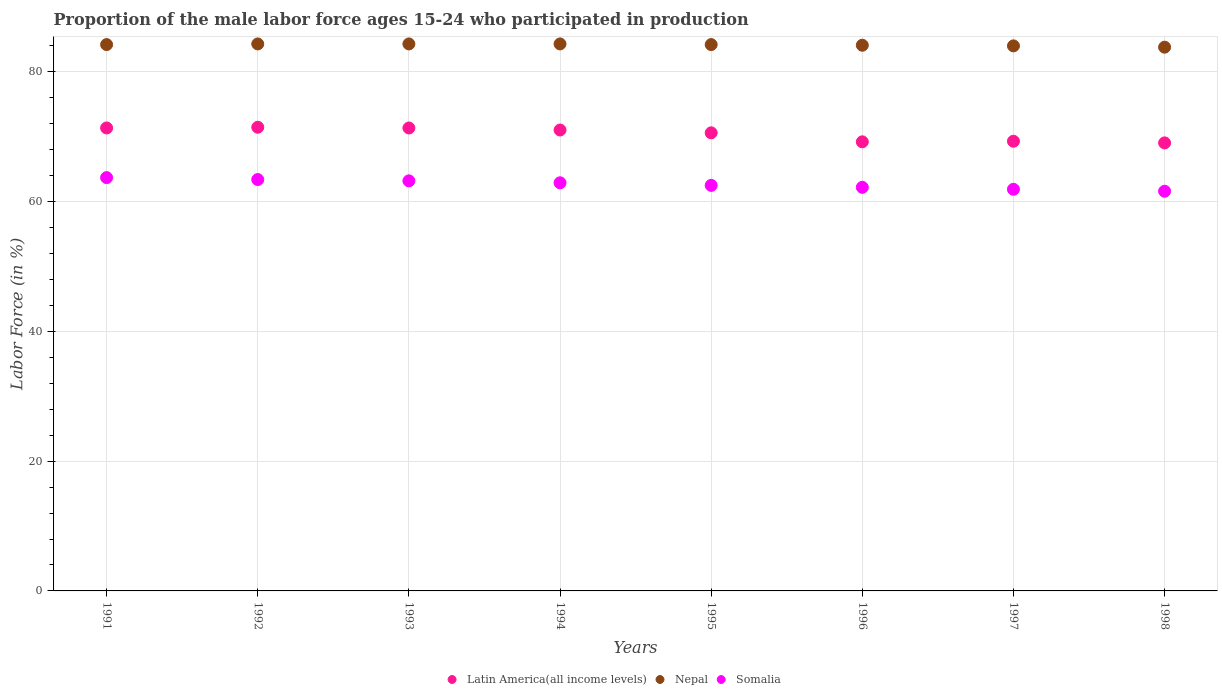How many different coloured dotlines are there?
Keep it short and to the point. 3. What is the proportion of the male labor force who participated in production in Somalia in 1998?
Ensure brevity in your answer.  61.6. Across all years, what is the maximum proportion of the male labor force who participated in production in Latin America(all income levels)?
Give a very brief answer. 71.46. Across all years, what is the minimum proportion of the male labor force who participated in production in Somalia?
Provide a succinct answer. 61.6. In which year was the proportion of the male labor force who participated in production in Nepal maximum?
Give a very brief answer. 1992. What is the total proportion of the male labor force who participated in production in Latin America(all income levels) in the graph?
Provide a short and direct response. 563.37. What is the difference between the proportion of the male labor force who participated in production in Somalia in 1997 and that in 1998?
Keep it short and to the point. 0.3. What is the difference between the proportion of the male labor force who participated in production in Nepal in 1991 and the proportion of the male labor force who participated in production in Latin America(all income levels) in 1994?
Your response must be concise. 13.17. What is the average proportion of the male labor force who participated in production in Latin America(all income levels) per year?
Your answer should be very brief. 70.42. In the year 1994, what is the difference between the proportion of the male labor force who participated in production in Somalia and proportion of the male labor force who participated in production in Nepal?
Make the answer very short. -21.4. In how many years, is the proportion of the male labor force who participated in production in Latin America(all income levels) greater than 72 %?
Your answer should be compact. 0. What is the ratio of the proportion of the male labor force who participated in production in Latin America(all income levels) in 1994 to that in 1996?
Your answer should be compact. 1.03. Is the proportion of the male labor force who participated in production in Latin America(all income levels) in 1995 less than that in 1998?
Offer a terse response. No. Is the difference between the proportion of the male labor force who participated in production in Somalia in 1993 and 1997 greater than the difference between the proportion of the male labor force who participated in production in Nepal in 1993 and 1997?
Your response must be concise. Yes. What is the difference between the highest and the second highest proportion of the male labor force who participated in production in Nepal?
Ensure brevity in your answer.  0. What is the difference between the highest and the lowest proportion of the male labor force who participated in production in Latin America(all income levels)?
Offer a very short reply. 2.41. Is the sum of the proportion of the male labor force who participated in production in Somalia in 1997 and 1998 greater than the maximum proportion of the male labor force who participated in production in Latin America(all income levels) across all years?
Provide a succinct answer. Yes. Is the proportion of the male labor force who participated in production in Somalia strictly less than the proportion of the male labor force who participated in production in Nepal over the years?
Provide a short and direct response. Yes. How many years are there in the graph?
Ensure brevity in your answer.  8. Does the graph contain grids?
Ensure brevity in your answer.  Yes. Where does the legend appear in the graph?
Provide a short and direct response. Bottom center. How many legend labels are there?
Offer a terse response. 3. What is the title of the graph?
Your response must be concise. Proportion of the male labor force ages 15-24 who participated in production. What is the Labor Force (in %) of Latin America(all income levels) in 1991?
Your answer should be very brief. 71.35. What is the Labor Force (in %) of Nepal in 1991?
Your answer should be very brief. 84.2. What is the Labor Force (in %) of Somalia in 1991?
Ensure brevity in your answer.  63.7. What is the Labor Force (in %) in Latin America(all income levels) in 1992?
Keep it short and to the point. 71.46. What is the Labor Force (in %) of Nepal in 1992?
Your answer should be compact. 84.3. What is the Labor Force (in %) of Somalia in 1992?
Keep it short and to the point. 63.4. What is the Labor Force (in %) of Latin America(all income levels) in 1993?
Provide a succinct answer. 71.35. What is the Labor Force (in %) in Nepal in 1993?
Give a very brief answer. 84.3. What is the Labor Force (in %) in Somalia in 1993?
Offer a terse response. 63.2. What is the Labor Force (in %) in Latin America(all income levels) in 1994?
Provide a succinct answer. 71.03. What is the Labor Force (in %) in Nepal in 1994?
Your answer should be very brief. 84.3. What is the Labor Force (in %) of Somalia in 1994?
Offer a terse response. 62.9. What is the Labor Force (in %) of Latin America(all income levels) in 1995?
Your answer should be very brief. 70.6. What is the Labor Force (in %) of Nepal in 1995?
Offer a very short reply. 84.2. What is the Labor Force (in %) in Somalia in 1995?
Keep it short and to the point. 62.5. What is the Labor Force (in %) of Latin America(all income levels) in 1996?
Make the answer very short. 69.21. What is the Labor Force (in %) in Nepal in 1996?
Your answer should be very brief. 84.1. What is the Labor Force (in %) in Somalia in 1996?
Offer a terse response. 62.2. What is the Labor Force (in %) in Latin America(all income levels) in 1997?
Ensure brevity in your answer.  69.31. What is the Labor Force (in %) of Somalia in 1997?
Keep it short and to the point. 61.9. What is the Labor Force (in %) of Latin America(all income levels) in 1998?
Provide a short and direct response. 69.05. What is the Labor Force (in %) of Nepal in 1998?
Provide a short and direct response. 83.8. What is the Labor Force (in %) of Somalia in 1998?
Ensure brevity in your answer.  61.6. Across all years, what is the maximum Labor Force (in %) in Latin America(all income levels)?
Provide a short and direct response. 71.46. Across all years, what is the maximum Labor Force (in %) in Nepal?
Make the answer very short. 84.3. Across all years, what is the maximum Labor Force (in %) of Somalia?
Your response must be concise. 63.7. Across all years, what is the minimum Labor Force (in %) in Latin America(all income levels)?
Provide a short and direct response. 69.05. Across all years, what is the minimum Labor Force (in %) in Nepal?
Your response must be concise. 83.8. Across all years, what is the minimum Labor Force (in %) of Somalia?
Provide a succinct answer. 61.6. What is the total Labor Force (in %) of Latin America(all income levels) in the graph?
Your answer should be very brief. 563.37. What is the total Labor Force (in %) of Nepal in the graph?
Your response must be concise. 673.2. What is the total Labor Force (in %) of Somalia in the graph?
Make the answer very short. 501.4. What is the difference between the Labor Force (in %) in Latin America(all income levels) in 1991 and that in 1992?
Give a very brief answer. -0.11. What is the difference between the Labor Force (in %) of Latin America(all income levels) in 1991 and that in 1993?
Ensure brevity in your answer.  0. What is the difference between the Labor Force (in %) in Nepal in 1991 and that in 1993?
Make the answer very short. -0.1. What is the difference between the Labor Force (in %) of Latin America(all income levels) in 1991 and that in 1994?
Your answer should be compact. 0.32. What is the difference between the Labor Force (in %) in Latin America(all income levels) in 1991 and that in 1995?
Offer a terse response. 0.75. What is the difference between the Labor Force (in %) in Nepal in 1991 and that in 1995?
Offer a terse response. 0. What is the difference between the Labor Force (in %) of Somalia in 1991 and that in 1995?
Provide a short and direct response. 1.2. What is the difference between the Labor Force (in %) in Latin America(all income levels) in 1991 and that in 1996?
Provide a succinct answer. 2.14. What is the difference between the Labor Force (in %) of Nepal in 1991 and that in 1996?
Offer a terse response. 0.1. What is the difference between the Labor Force (in %) in Latin America(all income levels) in 1991 and that in 1997?
Provide a succinct answer. 2.05. What is the difference between the Labor Force (in %) in Somalia in 1991 and that in 1997?
Provide a succinct answer. 1.8. What is the difference between the Labor Force (in %) of Latin America(all income levels) in 1991 and that in 1998?
Offer a very short reply. 2.3. What is the difference between the Labor Force (in %) in Nepal in 1991 and that in 1998?
Your response must be concise. 0.4. What is the difference between the Labor Force (in %) of Latin America(all income levels) in 1992 and that in 1993?
Your response must be concise. 0.11. What is the difference between the Labor Force (in %) in Nepal in 1992 and that in 1993?
Provide a succinct answer. 0. What is the difference between the Labor Force (in %) in Somalia in 1992 and that in 1993?
Offer a terse response. 0.2. What is the difference between the Labor Force (in %) of Latin America(all income levels) in 1992 and that in 1994?
Keep it short and to the point. 0.43. What is the difference between the Labor Force (in %) in Latin America(all income levels) in 1992 and that in 1995?
Your answer should be very brief. 0.86. What is the difference between the Labor Force (in %) of Nepal in 1992 and that in 1995?
Make the answer very short. 0.1. What is the difference between the Labor Force (in %) of Latin America(all income levels) in 1992 and that in 1996?
Give a very brief answer. 2.25. What is the difference between the Labor Force (in %) of Nepal in 1992 and that in 1996?
Offer a very short reply. 0.2. What is the difference between the Labor Force (in %) of Somalia in 1992 and that in 1996?
Ensure brevity in your answer.  1.2. What is the difference between the Labor Force (in %) in Latin America(all income levels) in 1992 and that in 1997?
Offer a terse response. 2.16. What is the difference between the Labor Force (in %) of Nepal in 1992 and that in 1997?
Offer a terse response. 0.3. What is the difference between the Labor Force (in %) in Somalia in 1992 and that in 1997?
Make the answer very short. 1.5. What is the difference between the Labor Force (in %) of Latin America(all income levels) in 1992 and that in 1998?
Your response must be concise. 2.41. What is the difference between the Labor Force (in %) of Latin America(all income levels) in 1993 and that in 1994?
Offer a terse response. 0.31. What is the difference between the Labor Force (in %) in Nepal in 1993 and that in 1994?
Offer a terse response. 0. What is the difference between the Labor Force (in %) of Somalia in 1993 and that in 1994?
Your response must be concise. 0.3. What is the difference between the Labor Force (in %) of Latin America(all income levels) in 1993 and that in 1995?
Provide a succinct answer. 0.75. What is the difference between the Labor Force (in %) in Nepal in 1993 and that in 1995?
Give a very brief answer. 0.1. What is the difference between the Labor Force (in %) in Somalia in 1993 and that in 1995?
Offer a very short reply. 0.7. What is the difference between the Labor Force (in %) in Latin America(all income levels) in 1993 and that in 1996?
Provide a short and direct response. 2.13. What is the difference between the Labor Force (in %) in Nepal in 1993 and that in 1996?
Your answer should be very brief. 0.2. What is the difference between the Labor Force (in %) in Somalia in 1993 and that in 1996?
Give a very brief answer. 1. What is the difference between the Labor Force (in %) in Latin America(all income levels) in 1993 and that in 1997?
Your answer should be compact. 2.04. What is the difference between the Labor Force (in %) of Nepal in 1993 and that in 1997?
Keep it short and to the point. 0.3. What is the difference between the Labor Force (in %) of Somalia in 1993 and that in 1997?
Your answer should be compact. 1.3. What is the difference between the Labor Force (in %) in Latin America(all income levels) in 1993 and that in 1998?
Offer a very short reply. 2.3. What is the difference between the Labor Force (in %) of Latin America(all income levels) in 1994 and that in 1995?
Ensure brevity in your answer.  0.43. What is the difference between the Labor Force (in %) of Nepal in 1994 and that in 1995?
Keep it short and to the point. 0.1. What is the difference between the Labor Force (in %) of Somalia in 1994 and that in 1995?
Keep it short and to the point. 0.4. What is the difference between the Labor Force (in %) of Latin America(all income levels) in 1994 and that in 1996?
Keep it short and to the point. 1.82. What is the difference between the Labor Force (in %) of Nepal in 1994 and that in 1996?
Make the answer very short. 0.2. What is the difference between the Labor Force (in %) of Latin America(all income levels) in 1994 and that in 1997?
Your answer should be compact. 1.73. What is the difference between the Labor Force (in %) in Somalia in 1994 and that in 1997?
Offer a terse response. 1. What is the difference between the Labor Force (in %) in Latin America(all income levels) in 1994 and that in 1998?
Ensure brevity in your answer.  1.98. What is the difference between the Labor Force (in %) in Latin America(all income levels) in 1995 and that in 1996?
Your answer should be very brief. 1.39. What is the difference between the Labor Force (in %) of Nepal in 1995 and that in 1996?
Offer a very short reply. 0.1. What is the difference between the Labor Force (in %) in Latin America(all income levels) in 1995 and that in 1997?
Your response must be concise. 1.3. What is the difference between the Labor Force (in %) in Somalia in 1995 and that in 1997?
Ensure brevity in your answer.  0.6. What is the difference between the Labor Force (in %) of Latin America(all income levels) in 1995 and that in 1998?
Ensure brevity in your answer.  1.55. What is the difference between the Labor Force (in %) of Latin America(all income levels) in 1996 and that in 1997?
Your answer should be very brief. -0.09. What is the difference between the Labor Force (in %) in Nepal in 1996 and that in 1997?
Provide a succinct answer. 0.1. What is the difference between the Labor Force (in %) of Somalia in 1996 and that in 1997?
Offer a very short reply. 0.3. What is the difference between the Labor Force (in %) of Latin America(all income levels) in 1996 and that in 1998?
Your response must be concise. 0.16. What is the difference between the Labor Force (in %) in Latin America(all income levels) in 1997 and that in 1998?
Provide a succinct answer. 0.26. What is the difference between the Labor Force (in %) in Latin America(all income levels) in 1991 and the Labor Force (in %) in Nepal in 1992?
Keep it short and to the point. -12.95. What is the difference between the Labor Force (in %) in Latin America(all income levels) in 1991 and the Labor Force (in %) in Somalia in 1992?
Provide a succinct answer. 7.95. What is the difference between the Labor Force (in %) of Nepal in 1991 and the Labor Force (in %) of Somalia in 1992?
Make the answer very short. 20.8. What is the difference between the Labor Force (in %) in Latin America(all income levels) in 1991 and the Labor Force (in %) in Nepal in 1993?
Your answer should be very brief. -12.95. What is the difference between the Labor Force (in %) of Latin America(all income levels) in 1991 and the Labor Force (in %) of Somalia in 1993?
Offer a terse response. 8.15. What is the difference between the Labor Force (in %) in Nepal in 1991 and the Labor Force (in %) in Somalia in 1993?
Offer a very short reply. 21. What is the difference between the Labor Force (in %) of Latin America(all income levels) in 1991 and the Labor Force (in %) of Nepal in 1994?
Ensure brevity in your answer.  -12.95. What is the difference between the Labor Force (in %) in Latin America(all income levels) in 1991 and the Labor Force (in %) in Somalia in 1994?
Provide a short and direct response. 8.45. What is the difference between the Labor Force (in %) of Nepal in 1991 and the Labor Force (in %) of Somalia in 1994?
Offer a very short reply. 21.3. What is the difference between the Labor Force (in %) of Latin America(all income levels) in 1991 and the Labor Force (in %) of Nepal in 1995?
Give a very brief answer. -12.85. What is the difference between the Labor Force (in %) in Latin America(all income levels) in 1991 and the Labor Force (in %) in Somalia in 1995?
Your answer should be compact. 8.85. What is the difference between the Labor Force (in %) in Nepal in 1991 and the Labor Force (in %) in Somalia in 1995?
Provide a short and direct response. 21.7. What is the difference between the Labor Force (in %) in Latin America(all income levels) in 1991 and the Labor Force (in %) in Nepal in 1996?
Provide a succinct answer. -12.75. What is the difference between the Labor Force (in %) in Latin America(all income levels) in 1991 and the Labor Force (in %) in Somalia in 1996?
Your response must be concise. 9.15. What is the difference between the Labor Force (in %) in Latin America(all income levels) in 1991 and the Labor Force (in %) in Nepal in 1997?
Provide a succinct answer. -12.65. What is the difference between the Labor Force (in %) in Latin America(all income levels) in 1991 and the Labor Force (in %) in Somalia in 1997?
Provide a succinct answer. 9.45. What is the difference between the Labor Force (in %) of Nepal in 1991 and the Labor Force (in %) of Somalia in 1997?
Ensure brevity in your answer.  22.3. What is the difference between the Labor Force (in %) of Latin America(all income levels) in 1991 and the Labor Force (in %) of Nepal in 1998?
Offer a terse response. -12.45. What is the difference between the Labor Force (in %) in Latin America(all income levels) in 1991 and the Labor Force (in %) in Somalia in 1998?
Your answer should be very brief. 9.75. What is the difference between the Labor Force (in %) in Nepal in 1991 and the Labor Force (in %) in Somalia in 1998?
Your answer should be very brief. 22.6. What is the difference between the Labor Force (in %) of Latin America(all income levels) in 1992 and the Labor Force (in %) of Nepal in 1993?
Your answer should be very brief. -12.84. What is the difference between the Labor Force (in %) of Latin America(all income levels) in 1992 and the Labor Force (in %) of Somalia in 1993?
Your answer should be very brief. 8.26. What is the difference between the Labor Force (in %) of Nepal in 1992 and the Labor Force (in %) of Somalia in 1993?
Ensure brevity in your answer.  21.1. What is the difference between the Labor Force (in %) of Latin America(all income levels) in 1992 and the Labor Force (in %) of Nepal in 1994?
Offer a very short reply. -12.84. What is the difference between the Labor Force (in %) of Latin America(all income levels) in 1992 and the Labor Force (in %) of Somalia in 1994?
Provide a succinct answer. 8.56. What is the difference between the Labor Force (in %) of Nepal in 1992 and the Labor Force (in %) of Somalia in 1994?
Ensure brevity in your answer.  21.4. What is the difference between the Labor Force (in %) of Latin America(all income levels) in 1992 and the Labor Force (in %) of Nepal in 1995?
Ensure brevity in your answer.  -12.74. What is the difference between the Labor Force (in %) of Latin America(all income levels) in 1992 and the Labor Force (in %) of Somalia in 1995?
Provide a short and direct response. 8.96. What is the difference between the Labor Force (in %) of Nepal in 1992 and the Labor Force (in %) of Somalia in 1995?
Give a very brief answer. 21.8. What is the difference between the Labor Force (in %) in Latin America(all income levels) in 1992 and the Labor Force (in %) in Nepal in 1996?
Your answer should be compact. -12.64. What is the difference between the Labor Force (in %) in Latin America(all income levels) in 1992 and the Labor Force (in %) in Somalia in 1996?
Give a very brief answer. 9.26. What is the difference between the Labor Force (in %) in Nepal in 1992 and the Labor Force (in %) in Somalia in 1996?
Give a very brief answer. 22.1. What is the difference between the Labor Force (in %) of Latin America(all income levels) in 1992 and the Labor Force (in %) of Nepal in 1997?
Provide a short and direct response. -12.54. What is the difference between the Labor Force (in %) in Latin America(all income levels) in 1992 and the Labor Force (in %) in Somalia in 1997?
Your answer should be compact. 9.56. What is the difference between the Labor Force (in %) of Nepal in 1992 and the Labor Force (in %) of Somalia in 1997?
Offer a very short reply. 22.4. What is the difference between the Labor Force (in %) of Latin America(all income levels) in 1992 and the Labor Force (in %) of Nepal in 1998?
Make the answer very short. -12.34. What is the difference between the Labor Force (in %) in Latin America(all income levels) in 1992 and the Labor Force (in %) in Somalia in 1998?
Your response must be concise. 9.86. What is the difference between the Labor Force (in %) in Nepal in 1992 and the Labor Force (in %) in Somalia in 1998?
Offer a terse response. 22.7. What is the difference between the Labor Force (in %) in Latin America(all income levels) in 1993 and the Labor Force (in %) in Nepal in 1994?
Offer a terse response. -12.95. What is the difference between the Labor Force (in %) in Latin America(all income levels) in 1993 and the Labor Force (in %) in Somalia in 1994?
Ensure brevity in your answer.  8.45. What is the difference between the Labor Force (in %) of Nepal in 1993 and the Labor Force (in %) of Somalia in 1994?
Ensure brevity in your answer.  21.4. What is the difference between the Labor Force (in %) of Latin America(all income levels) in 1993 and the Labor Force (in %) of Nepal in 1995?
Ensure brevity in your answer.  -12.85. What is the difference between the Labor Force (in %) of Latin America(all income levels) in 1993 and the Labor Force (in %) of Somalia in 1995?
Your answer should be compact. 8.85. What is the difference between the Labor Force (in %) of Nepal in 1993 and the Labor Force (in %) of Somalia in 1995?
Your response must be concise. 21.8. What is the difference between the Labor Force (in %) of Latin America(all income levels) in 1993 and the Labor Force (in %) of Nepal in 1996?
Provide a succinct answer. -12.75. What is the difference between the Labor Force (in %) of Latin America(all income levels) in 1993 and the Labor Force (in %) of Somalia in 1996?
Make the answer very short. 9.15. What is the difference between the Labor Force (in %) of Nepal in 1993 and the Labor Force (in %) of Somalia in 1996?
Ensure brevity in your answer.  22.1. What is the difference between the Labor Force (in %) of Latin America(all income levels) in 1993 and the Labor Force (in %) of Nepal in 1997?
Your response must be concise. -12.65. What is the difference between the Labor Force (in %) of Latin America(all income levels) in 1993 and the Labor Force (in %) of Somalia in 1997?
Make the answer very short. 9.45. What is the difference between the Labor Force (in %) in Nepal in 1993 and the Labor Force (in %) in Somalia in 1997?
Your answer should be compact. 22.4. What is the difference between the Labor Force (in %) in Latin America(all income levels) in 1993 and the Labor Force (in %) in Nepal in 1998?
Provide a short and direct response. -12.45. What is the difference between the Labor Force (in %) of Latin America(all income levels) in 1993 and the Labor Force (in %) of Somalia in 1998?
Your answer should be compact. 9.75. What is the difference between the Labor Force (in %) in Nepal in 1993 and the Labor Force (in %) in Somalia in 1998?
Your response must be concise. 22.7. What is the difference between the Labor Force (in %) of Latin America(all income levels) in 1994 and the Labor Force (in %) of Nepal in 1995?
Give a very brief answer. -13.17. What is the difference between the Labor Force (in %) in Latin America(all income levels) in 1994 and the Labor Force (in %) in Somalia in 1995?
Give a very brief answer. 8.53. What is the difference between the Labor Force (in %) of Nepal in 1994 and the Labor Force (in %) of Somalia in 1995?
Your answer should be compact. 21.8. What is the difference between the Labor Force (in %) of Latin America(all income levels) in 1994 and the Labor Force (in %) of Nepal in 1996?
Keep it short and to the point. -13.07. What is the difference between the Labor Force (in %) in Latin America(all income levels) in 1994 and the Labor Force (in %) in Somalia in 1996?
Provide a short and direct response. 8.83. What is the difference between the Labor Force (in %) of Nepal in 1994 and the Labor Force (in %) of Somalia in 1996?
Ensure brevity in your answer.  22.1. What is the difference between the Labor Force (in %) of Latin America(all income levels) in 1994 and the Labor Force (in %) of Nepal in 1997?
Offer a very short reply. -12.97. What is the difference between the Labor Force (in %) in Latin America(all income levels) in 1994 and the Labor Force (in %) in Somalia in 1997?
Offer a very short reply. 9.13. What is the difference between the Labor Force (in %) in Nepal in 1994 and the Labor Force (in %) in Somalia in 1997?
Offer a terse response. 22.4. What is the difference between the Labor Force (in %) in Latin America(all income levels) in 1994 and the Labor Force (in %) in Nepal in 1998?
Make the answer very short. -12.77. What is the difference between the Labor Force (in %) of Latin America(all income levels) in 1994 and the Labor Force (in %) of Somalia in 1998?
Your answer should be compact. 9.43. What is the difference between the Labor Force (in %) of Nepal in 1994 and the Labor Force (in %) of Somalia in 1998?
Offer a terse response. 22.7. What is the difference between the Labor Force (in %) of Latin America(all income levels) in 1995 and the Labor Force (in %) of Nepal in 1996?
Keep it short and to the point. -13.5. What is the difference between the Labor Force (in %) of Latin America(all income levels) in 1995 and the Labor Force (in %) of Somalia in 1996?
Make the answer very short. 8.4. What is the difference between the Labor Force (in %) in Nepal in 1995 and the Labor Force (in %) in Somalia in 1996?
Offer a very short reply. 22. What is the difference between the Labor Force (in %) of Latin America(all income levels) in 1995 and the Labor Force (in %) of Nepal in 1997?
Your answer should be compact. -13.4. What is the difference between the Labor Force (in %) of Latin America(all income levels) in 1995 and the Labor Force (in %) of Somalia in 1997?
Your response must be concise. 8.7. What is the difference between the Labor Force (in %) in Nepal in 1995 and the Labor Force (in %) in Somalia in 1997?
Give a very brief answer. 22.3. What is the difference between the Labor Force (in %) of Latin America(all income levels) in 1995 and the Labor Force (in %) of Nepal in 1998?
Keep it short and to the point. -13.2. What is the difference between the Labor Force (in %) in Latin America(all income levels) in 1995 and the Labor Force (in %) in Somalia in 1998?
Your response must be concise. 9. What is the difference between the Labor Force (in %) of Nepal in 1995 and the Labor Force (in %) of Somalia in 1998?
Ensure brevity in your answer.  22.6. What is the difference between the Labor Force (in %) of Latin America(all income levels) in 1996 and the Labor Force (in %) of Nepal in 1997?
Offer a very short reply. -14.79. What is the difference between the Labor Force (in %) in Latin America(all income levels) in 1996 and the Labor Force (in %) in Somalia in 1997?
Your answer should be very brief. 7.31. What is the difference between the Labor Force (in %) in Latin America(all income levels) in 1996 and the Labor Force (in %) in Nepal in 1998?
Your answer should be very brief. -14.59. What is the difference between the Labor Force (in %) in Latin America(all income levels) in 1996 and the Labor Force (in %) in Somalia in 1998?
Make the answer very short. 7.61. What is the difference between the Labor Force (in %) of Nepal in 1996 and the Labor Force (in %) of Somalia in 1998?
Provide a short and direct response. 22.5. What is the difference between the Labor Force (in %) in Latin America(all income levels) in 1997 and the Labor Force (in %) in Nepal in 1998?
Provide a succinct answer. -14.49. What is the difference between the Labor Force (in %) in Latin America(all income levels) in 1997 and the Labor Force (in %) in Somalia in 1998?
Your answer should be very brief. 7.71. What is the difference between the Labor Force (in %) of Nepal in 1997 and the Labor Force (in %) of Somalia in 1998?
Provide a short and direct response. 22.4. What is the average Labor Force (in %) of Latin America(all income levels) per year?
Ensure brevity in your answer.  70.42. What is the average Labor Force (in %) in Nepal per year?
Give a very brief answer. 84.15. What is the average Labor Force (in %) in Somalia per year?
Provide a short and direct response. 62.67. In the year 1991, what is the difference between the Labor Force (in %) in Latin America(all income levels) and Labor Force (in %) in Nepal?
Provide a succinct answer. -12.85. In the year 1991, what is the difference between the Labor Force (in %) of Latin America(all income levels) and Labor Force (in %) of Somalia?
Provide a succinct answer. 7.65. In the year 1991, what is the difference between the Labor Force (in %) of Nepal and Labor Force (in %) of Somalia?
Provide a short and direct response. 20.5. In the year 1992, what is the difference between the Labor Force (in %) of Latin America(all income levels) and Labor Force (in %) of Nepal?
Offer a very short reply. -12.84. In the year 1992, what is the difference between the Labor Force (in %) in Latin America(all income levels) and Labor Force (in %) in Somalia?
Make the answer very short. 8.06. In the year 1992, what is the difference between the Labor Force (in %) in Nepal and Labor Force (in %) in Somalia?
Your answer should be compact. 20.9. In the year 1993, what is the difference between the Labor Force (in %) of Latin America(all income levels) and Labor Force (in %) of Nepal?
Your answer should be very brief. -12.95. In the year 1993, what is the difference between the Labor Force (in %) in Latin America(all income levels) and Labor Force (in %) in Somalia?
Offer a terse response. 8.15. In the year 1993, what is the difference between the Labor Force (in %) in Nepal and Labor Force (in %) in Somalia?
Offer a terse response. 21.1. In the year 1994, what is the difference between the Labor Force (in %) in Latin America(all income levels) and Labor Force (in %) in Nepal?
Make the answer very short. -13.27. In the year 1994, what is the difference between the Labor Force (in %) of Latin America(all income levels) and Labor Force (in %) of Somalia?
Keep it short and to the point. 8.13. In the year 1994, what is the difference between the Labor Force (in %) of Nepal and Labor Force (in %) of Somalia?
Keep it short and to the point. 21.4. In the year 1995, what is the difference between the Labor Force (in %) in Latin America(all income levels) and Labor Force (in %) in Nepal?
Give a very brief answer. -13.6. In the year 1995, what is the difference between the Labor Force (in %) in Latin America(all income levels) and Labor Force (in %) in Somalia?
Ensure brevity in your answer.  8.1. In the year 1995, what is the difference between the Labor Force (in %) of Nepal and Labor Force (in %) of Somalia?
Your answer should be very brief. 21.7. In the year 1996, what is the difference between the Labor Force (in %) of Latin America(all income levels) and Labor Force (in %) of Nepal?
Give a very brief answer. -14.89. In the year 1996, what is the difference between the Labor Force (in %) in Latin America(all income levels) and Labor Force (in %) in Somalia?
Offer a very short reply. 7.01. In the year 1996, what is the difference between the Labor Force (in %) in Nepal and Labor Force (in %) in Somalia?
Your answer should be very brief. 21.9. In the year 1997, what is the difference between the Labor Force (in %) in Latin America(all income levels) and Labor Force (in %) in Nepal?
Provide a succinct answer. -14.69. In the year 1997, what is the difference between the Labor Force (in %) of Latin America(all income levels) and Labor Force (in %) of Somalia?
Provide a short and direct response. 7.41. In the year 1997, what is the difference between the Labor Force (in %) of Nepal and Labor Force (in %) of Somalia?
Give a very brief answer. 22.1. In the year 1998, what is the difference between the Labor Force (in %) of Latin America(all income levels) and Labor Force (in %) of Nepal?
Give a very brief answer. -14.75. In the year 1998, what is the difference between the Labor Force (in %) of Latin America(all income levels) and Labor Force (in %) of Somalia?
Your response must be concise. 7.45. In the year 1998, what is the difference between the Labor Force (in %) in Nepal and Labor Force (in %) in Somalia?
Offer a very short reply. 22.2. What is the ratio of the Labor Force (in %) of Latin America(all income levels) in 1991 to that in 1992?
Keep it short and to the point. 1. What is the ratio of the Labor Force (in %) of Somalia in 1991 to that in 1992?
Provide a succinct answer. 1. What is the ratio of the Labor Force (in %) in Latin America(all income levels) in 1991 to that in 1993?
Your answer should be compact. 1. What is the ratio of the Labor Force (in %) in Somalia in 1991 to that in 1993?
Your response must be concise. 1.01. What is the ratio of the Labor Force (in %) of Somalia in 1991 to that in 1994?
Give a very brief answer. 1.01. What is the ratio of the Labor Force (in %) in Latin America(all income levels) in 1991 to that in 1995?
Your response must be concise. 1.01. What is the ratio of the Labor Force (in %) of Somalia in 1991 to that in 1995?
Ensure brevity in your answer.  1.02. What is the ratio of the Labor Force (in %) in Latin America(all income levels) in 1991 to that in 1996?
Provide a short and direct response. 1.03. What is the ratio of the Labor Force (in %) in Nepal in 1991 to that in 1996?
Offer a very short reply. 1. What is the ratio of the Labor Force (in %) in Somalia in 1991 to that in 1996?
Your answer should be very brief. 1.02. What is the ratio of the Labor Force (in %) in Latin America(all income levels) in 1991 to that in 1997?
Offer a terse response. 1.03. What is the ratio of the Labor Force (in %) in Somalia in 1991 to that in 1997?
Give a very brief answer. 1.03. What is the ratio of the Labor Force (in %) in Latin America(all income levels) in 1991 to that in 1998?
Provide a short and direct response. 1.03. What is the ratio of the Labor Force (in %) of Somalia in 1991 to that in 1998?
Your answer should be compact. 1.03. What is the ratio of the Labor Force (in %) of Latin America(all income levels) in 1992 to that in 1993?
Offer a very short reply. 1. What is the ratio of the Labor Force (in %) of Nepal in 1992 to that in 1993?
Keep it short and to the point. 1. What is the ratio of the Labor Force (in %) in Somalia in 1992 to that in 1993?
Give a very brief answer. 1. What is the ratio of the Labor Force (in %) in Latin America(all income levels) in 1992 to that in 1994?
Your answer should be very brief. 1.01. What is the ratio of the Labor Force (in %) in Nepal in 1992 to that in 1994?
Ensure brevity in your answer.  1. What is the ratio of the Labor Force (in %) in Somalia in 1992 to that in 1994?
Your response must be concise. 1.01. What is the ratio of the Labor Force (in %) in Latin America(all income levels) in 1992 to that in 1995?
Give a very brief answer. 1.01. What is the ratio of the Labor Force (in %) of Nepal in 1992 to that in 1995?
Ensure brevity in your answer.  1. What is the ratio of the Labor Force (in %) in Somalia in 1992 to that in 1995?
Give a very brief answer. 1.01. What is the ratio of the Labor Force (in %) of Latin America(all income levels) in 1992 to that in 1996?
Your response must be concise. 1.03. What is the ratio of the Labor Force (in %) of Nepal in 1992 to that in 1996?
Keep it short and to the point. 1. What is the ratio of the Labor Force (in %) of Somalia in 1992 to that in 1996?
Give a very brief answer. 1.02. What is the ratio of the Labor Force (in %) of Latin America(all income levels) in 1992 to that in 1997?
Make the answer very short. 1.03. What is the ratio of the Labor Force (in %) in Somalia in 1992 to that in 1997?
Offer a terse response. 1.02. What is the ratio of the Labor Force (in %) of Latin America(all income levels) in 1992 to that in 1998?
Keep it short and to the point. 1.03. What is the ratio of the Labor Force (in %) in Somalia in 1992 to that in 1998?
Ensure brevity in your answer.  1.03. What is the ratio of the Labor Force (in %) of Nepal in 1993 to that in 1994?
Provide a succinct answer. 1. What is the ratio of the Labor Force (in %) of Somalia in 1993 to that in 1994?
Offer a terse response. 1. What is the ratio of the Labor Force (in %) of Latin America(all income levels) in 1993 to that in 1995?
Give a very brief answer. 1.01. What is the ratio of the Labor Force (in %) in Nepal in 1993 to that in 1995?
Ensure brevity in your answer.  1. What is the ratio of the Labor Force (in %) of Somalia in 1993 to that in 1995?
Your answer should be very brief. 1.01. What is the ratio of the Labor Force (in %) in Latin America(all income levels) in 1993 to that in 1996?
Offer a terse response. 1.03. What is the ratio of the Labor Force (in %) in Nepal in 1993 to that in 1996?
Provide a short and direct response. 1. What is the ratio of the Labor Force (in %) in Somalia in 1993 to that in 1996?
Your answer should be compact. 1.02. What is the ratio of the Labor Force (in %) of Latin America(all income levels) in 1993 to that in 1997?
Offer a terse response. 1.03. What is the ratio of the Labor Force (in %) in Nepal in 1993 to that in 1997?
Give a very brief answer. 1. What is the ratio of the Labor Force (in %) in Somalia in 1993 to that in 1997?
Your response must be concise. 1.02. What is the ratio of the Labor Force (in %) in Nepal in 1993 to that in 1998?
Your response must be concise. 1.01. What is the ratio of the Labor Force (in %) in Latin America(all income levels) in 1994 to that in 1995?
Provide a short and direct response. 1.01. What is the ratio of the Labor Force (in %) in Nepal in 1994 to that in 1995?
Ensure brevity in your answer.  1. What is the ratio of the Labor Force (in %) in Somalia in 1994 to that in 1995?
Keep it short and to the point. 1.01. What is the ratio of the Labor Force (in %) in Latin America(all income levels) in 1994 to that in 1996?
Make the answer very short. 1.03. What is the ratio of the Labor Force (in %) in Somalia in 1994 to that in 1996?
Make the answer very short. 1.01. What is the ratio of the Labor Force (in %) of Somalia in 1994 to that in 1997?
Your response must be concise. 1.02. What is the ratio of the Labor Force (in %) in Latin America(all income levels) in 1994 to that in 1998?
Provide a succinct answer. 1.03. What is the ratio of the Labor Force (in %) in Somalia in 1994 to that in 1998?
Your response must be concise. 1.02. What is the ratio of the Labor Force (in %) in Nepal in 1995 to that in 1996?
Keep it short and to the point. 1. What is the ratio of the Labor Force (in %) in Latin America(all income levels) in 1995 to that in 1997?
Your answer should be compact. 1.02. What is the ratio of the Labor Force (in %) in Nepal in 1995 to that in 1997?
Give a very brief answer. 1. What is the ratio of the Labor Force (in %) of Somalia in 1995 to that in 1997?
Keep it short and to the point. 1.01. What is the ratio of the Labor Force (in %) of Latin America(all income levels) in 1995 to that in 1998?
Provide a short and direct response. 1.02. What is the ratio of the Labor Force (in %) of Nepal in 1995 to that in 1998?
Your answer should be compact. 1. What is the ratio of the Labor Force (in %) of Somalia in 1995 to that in 1998?
Your answer should be very brief. 1.01. What is the ratio of the Labor Force (in %) of Latin America(all income levels) in 1996 to that in 1997?
Give a very brief answer. 1. What is the ratio of the Labor Force (in %) in Somalia in 1996 to that in 1997?
Your response must be concise. 1. What is the ratio of the Labor Force (in %) in Nepal in 1996 to that in 1998?
Give a very brief answer. 1. What is the ratio of the Labor Force (in %) of Somalia in 1996 to that in 1998?
Provide a succinct answer. 1.01. What is the ratio of the Labor Force (in %) of Latin America(all income levels) in 1997 to that in 1998?
Provide a short and direct response. 1. What is the ratio of the Labor Force (in %) in Somalia in 1997 to that in 1998?
Your answer should be compact. 1. What is the difference between the highest and the second highest Labor Force (in %) of Latin America(all income levels)?
Your answer should be very brief. 0.11. What is the difference between the highest and the second highest Labor Force (in %) of Somalia?
Provide a succinct answer. 0.3. What is the difference between the highest and the lowest Labor Force (in %) of Latin America(all income levels)?
Ensure brevity in your answer.  2.41. What is the difference between the highest and the lowest Labor Force (in %) in Somalia?
Your answer should be compact. 2.1. 